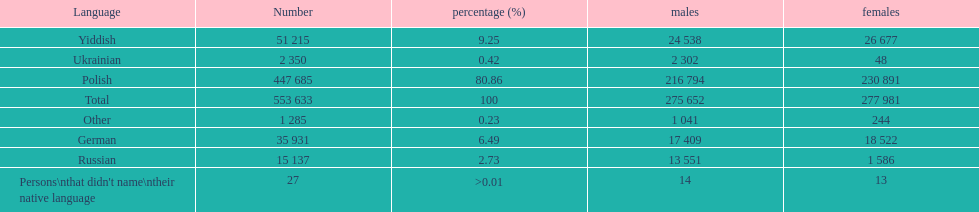How many speakers (of any language) are represented on the table ? 553 633. 